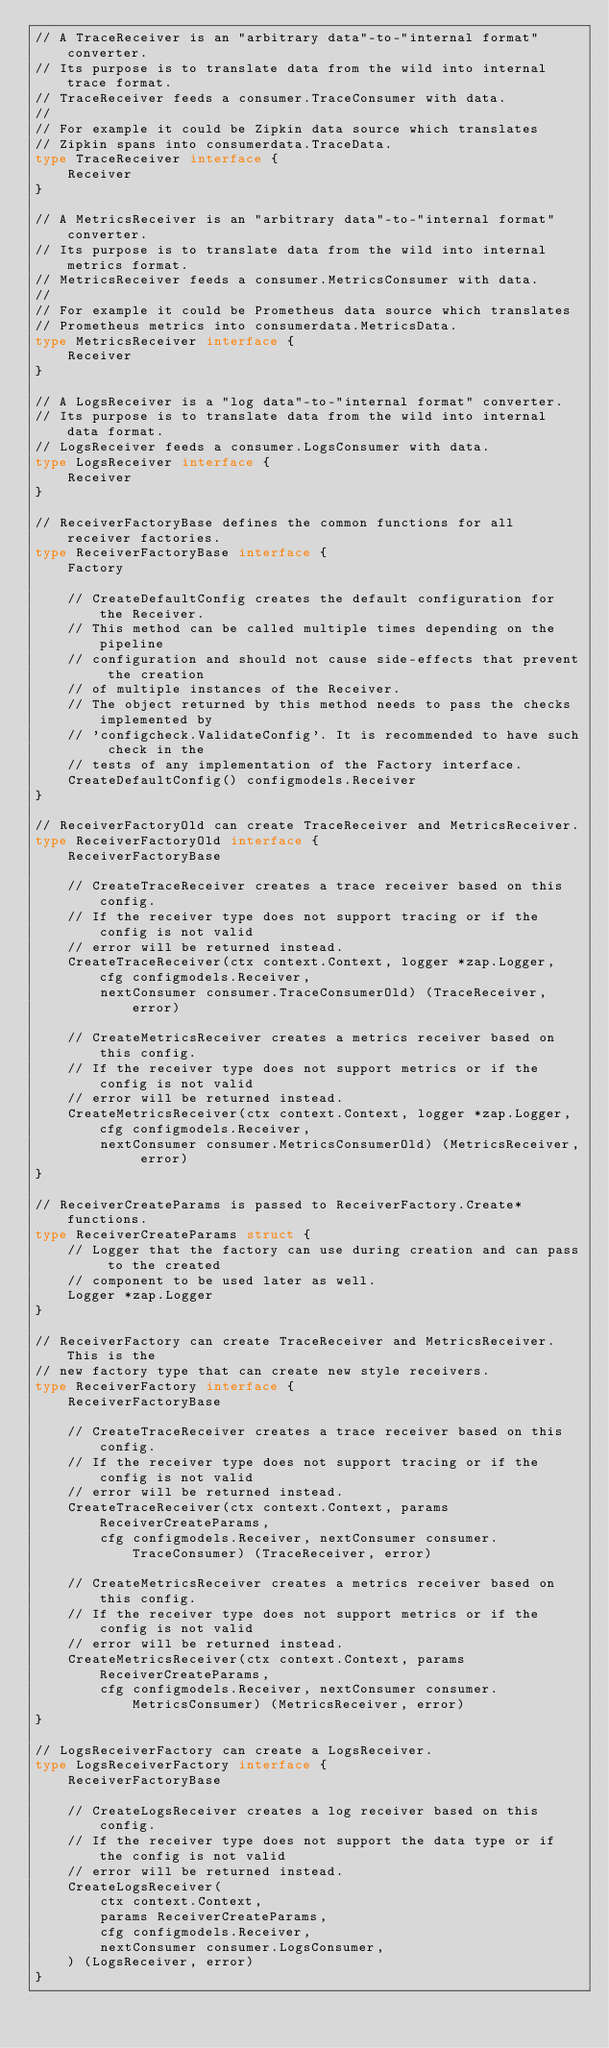Convert code to text. <code><loc_0><loc_0><loc_500><loc_500><_Go_>// A TraceReceiver is an "arbitrary data"-to-"internal format" converter.
// Its purpose is to translate data from the wild into internal trace format.
// TraceReceiver feeds a consumer.TraceConsumer with data.
//
// For example it could be Zipkin data source which translates
// Zipkin spans into consumerdata.TraceData.
type TraceReceiver interface {
	Receiver
}

// A MetricsReceiver is an "arbitrary data"-to-"internal format" converter.
// Its purpose is to translate data from the wild into internal metrics format.
// MetricsReceiver feeds a consumer.MetricsConsumer with data.
//
// For example it could be Prometheus data source which translates
// Prometheus metrics into consumerdata.MetricsData.
type MetricsReceiver interface {
	Receiver
}

// A LogsReceiver is a "log data"-to-"internal format" converter.
// Its purpose is to translate data from the wild into internal data format.
// LogsReceiver feeds a consumer.LogsConsumer with data.
type LogsReceiver interface {
	Receiver
}

// ReceiverFactoryBase defines the common functions for all receiver factories.
type ReceiverFactoryBase interface {
	Factory

	// CreateDefaultConfig creates the default configuration for the Receiver.
	// This method can be called multiple times depending on the pipeline
	// configuration and should not cause side-effects that prevent the creation
	// of multiple instances of the Receiver.
	// The object returned by this method needs to pass the checks implemented by
	// 'configcheck.ValidateConfig'. It is recommended to have such check in the
	// tests of any implementation of the Factory interface.
	CreateDefaultConfig() configmodels.Receiver
}

// ReceiverFactoryOld can create TraceReceiver and MetricsReceiver.
type ReceiverFactoryOld interface {
	ReceiverFactoryBase

	// CreateTraceReceiver creates a trace receiver based on this config.
	// If the receiver type does not support tracing or if the config is not valid
	// error will be returned instead.
	CreateTraceReceiver(ctx context.Context, logger *zap.Logger, cfg configmodels.Receiver,
		nextConsumer consumer.TraceConsumerOld) (TraceReceiver, error)

	// CreateMetricsReceiver creates a metrics receiver based on this config.
	// If the receiver type does not support metrics or if the config is not valid
	// error will be returned instead.
	CreateMetricsReceiver(ctx context.Context, logger *zap.Logger, cfg configmodels.Receiver,
		nextConsumer consumer.MetricsConsumerOld) (MetricsReceiver, error)
}

// ReceiverCreateParams is passed to ReceiverFactory.Create* functions.
type ReceiverCreateParams struct {
	// Logger that the factory can use during creation and can pass to the created
	// component to be used later as well.
	Logger *zap.Logger
}

// ReceiverFactory can create TraceReceiver and MetricsReceiver. This is the
// new factory type that can create new style receivers.
type ReceiverFactory interface {
	ReceiverFactoryBase

	// CreateTraceReceiver creates a trace receiver based on this config.
	// If the receiver type does not support tracing or if the config is not valid
	// error will be returned instead.
	CreateTraceReceiver(ctx context.Context, params ReceiverCreateParams,
		cfg configmodels.Receiver, nextConsumer consumer.TraceConsumer) (TraceReceiver, error)

	// CreateMetricsReceiver creates a metrics receiver based on this config.
	// If the receiver type does not support metrics or if the config is not valid
	// error will be returned instead.
	CreateMetricsReceiver(ctx context.Context, params ReceiverCreateParams,
		cfg configmodels.Receiver, nextConsumer consumer.MetricsConsumer) (MetricsReceiver, error)
}

// LogsReceiverFactory can create a LogsReceiver.
type LogsReceiverFactory interface {
	ReceiverFactoryBase

	// CreateLogsReceiver creates a log receiver based on this config.
	// If the receiver type does not support the data type or if the config is not valid
	// error will be returned instead.
	CreateLogsReceiver(
		ctx context.Context,
		params ReceiverCreateParams,
		cfg configmodels.Receiver,
		nextConsumer consumer.LogsConsumer,
	) (LogsReceiver, error)
}
</code> 